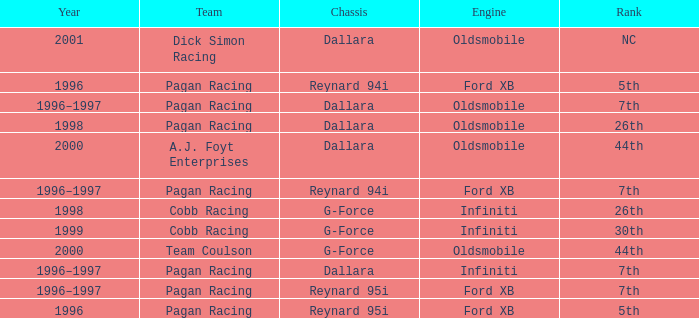What engine was used in 1999? Infiniti. 